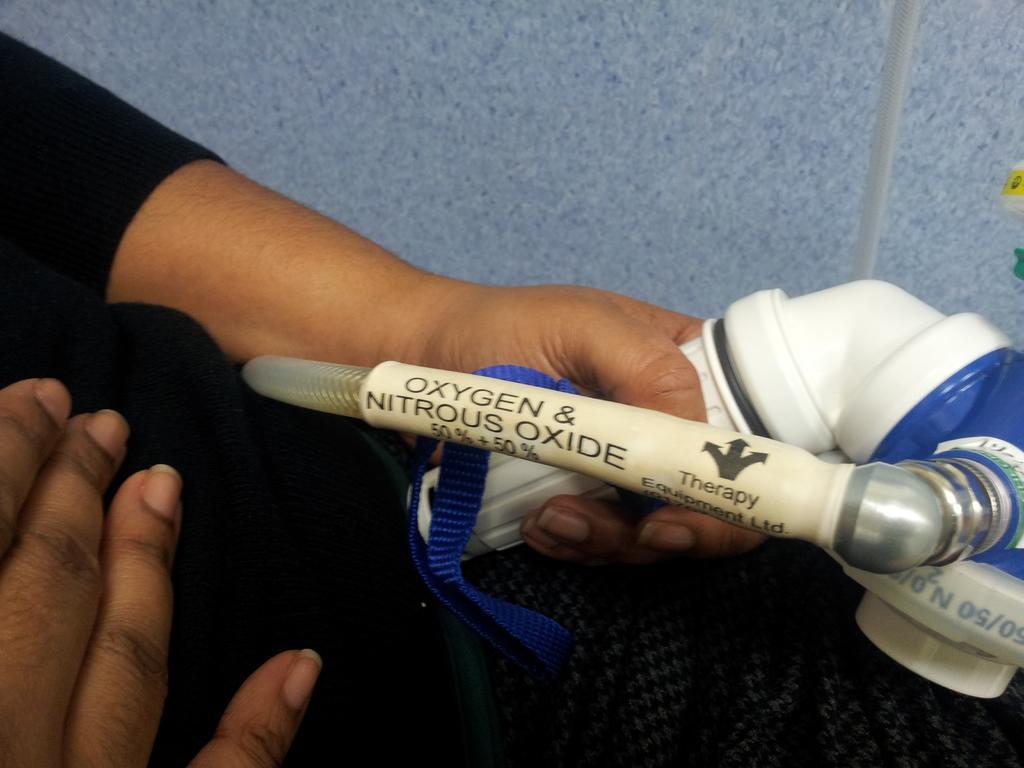Could you give a brief overview of what you see in this image? In this picture there is a lady on the left side of the image, by holding an oxygen pipe in her hand. 